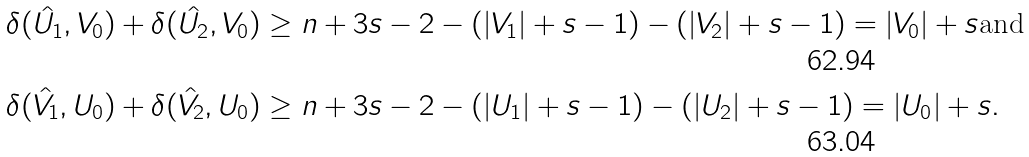<formula> <loc_0><loc_0><loc_500><loc_500>\delta ( \hat { U _ { 1 } } , V _ { 0 } ) + \delta ( \hat { U _ { 2 } } , V _ { 0 } ) & \geq n + 3 s - 2 - ( | V _ { 1 } | + s - 1 ) - ( | V _ { 2 } | + s - 1 ) = | V _ { 0 } | + s \text {and} \\ \delta ( \hat { V _ { 1 } } , U _ { 0 } ) + \delta ( \hat { V _ { 2 } } , U _ { 0 } ) & \geq n + 3 s - 2 - ( | U _ { 1 } | + s - 1 ) - ( | U _ { 2 } | + s - 1 ) = | U _ { 0 } | + s .</formula> 